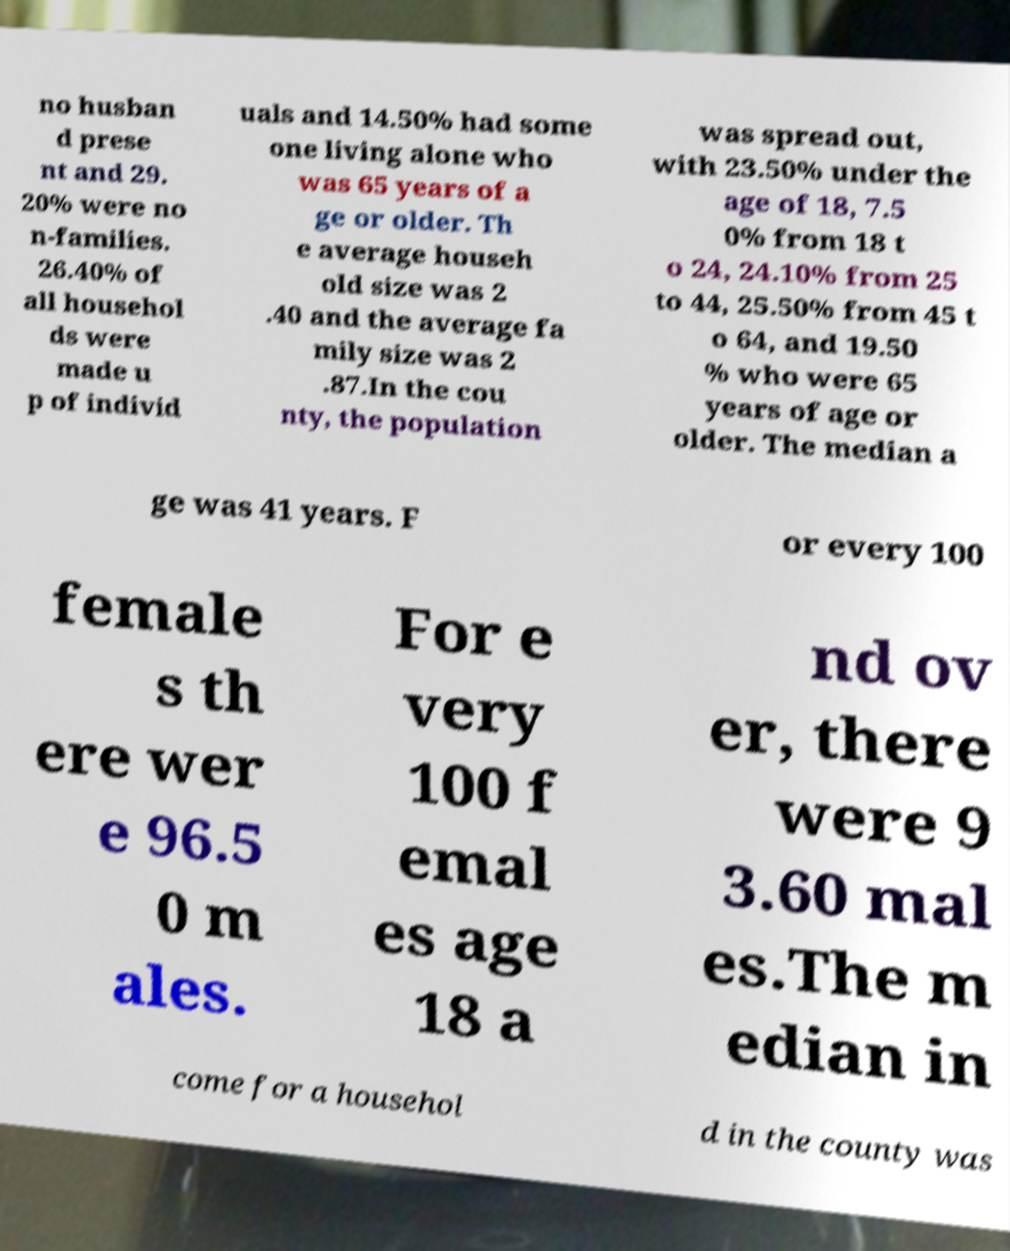Could you extract and type out the text from this image? no husban d prese nt and 29. 20% were no n-families. 26.40% of all househol ds were made u p of individ uals and 14.50% had some one living alone who was 65 years of a ge or older. Th e average househ old size was 2 .40 and the average fa mily size was 2 .87.In the cou nty, the population was spread out, with 23.50% under the age of 18, 7.5 0% from 18 t o 24, 24.10% from 25 to 44, 25.50% from 45 t o 64, and 19.50 % who were 65 years of age or older. The median a ge was 41 years. F or every 100 female s th ere wer e 96.5 0 m ales. For e very 100 f emal es age 18 a nd ov er, there were 9 3.60 mal es.The m edian in come for a househol d in the county was 